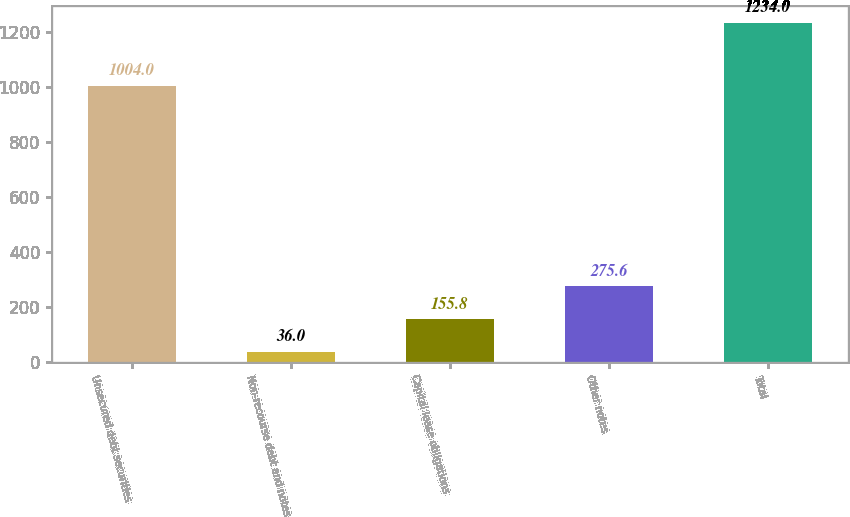Convert chart. <chart><loc_0><loc_0><loc_500><loc_500><bar_chart><fcel>Unsecured debt securities<fcel>Non-recourse debt and notes<fcel>Capital lease obligations<fcel>Other notes<fcel>Total<nl><fcel>1004<fcel>36<fcel>155.8<fcel>275.6<fcel>1234<nl></chart> 